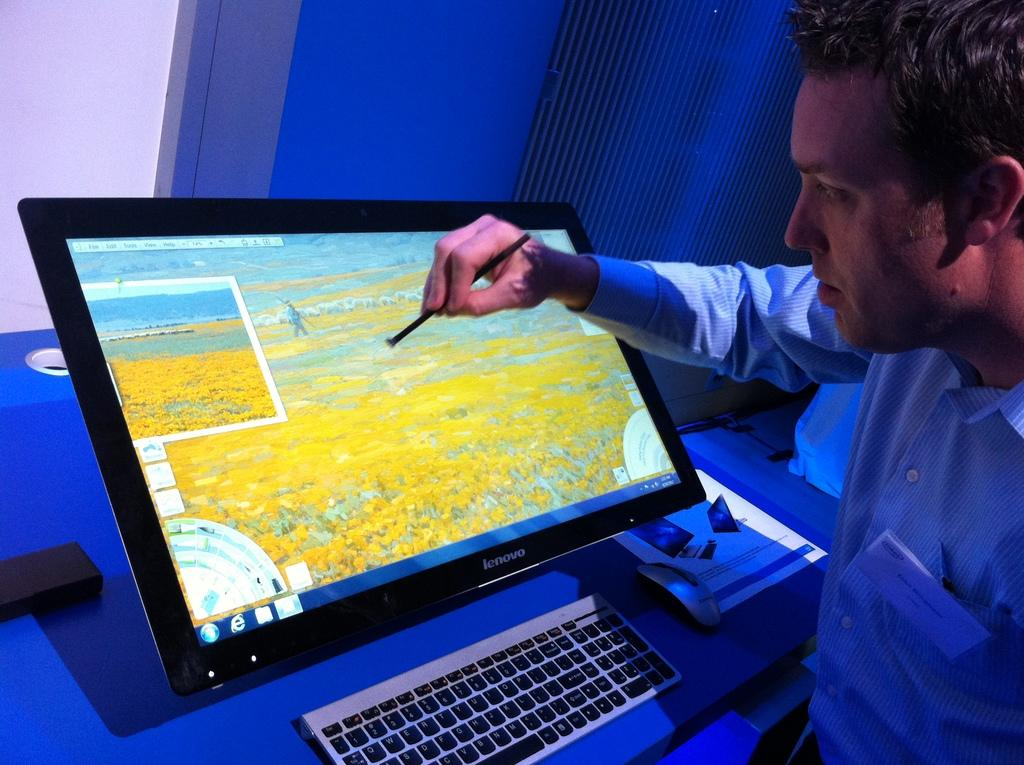<image>
Relay a brief, clear account of the picture shown. A man using a stylus on a Lenovo computer screen. 